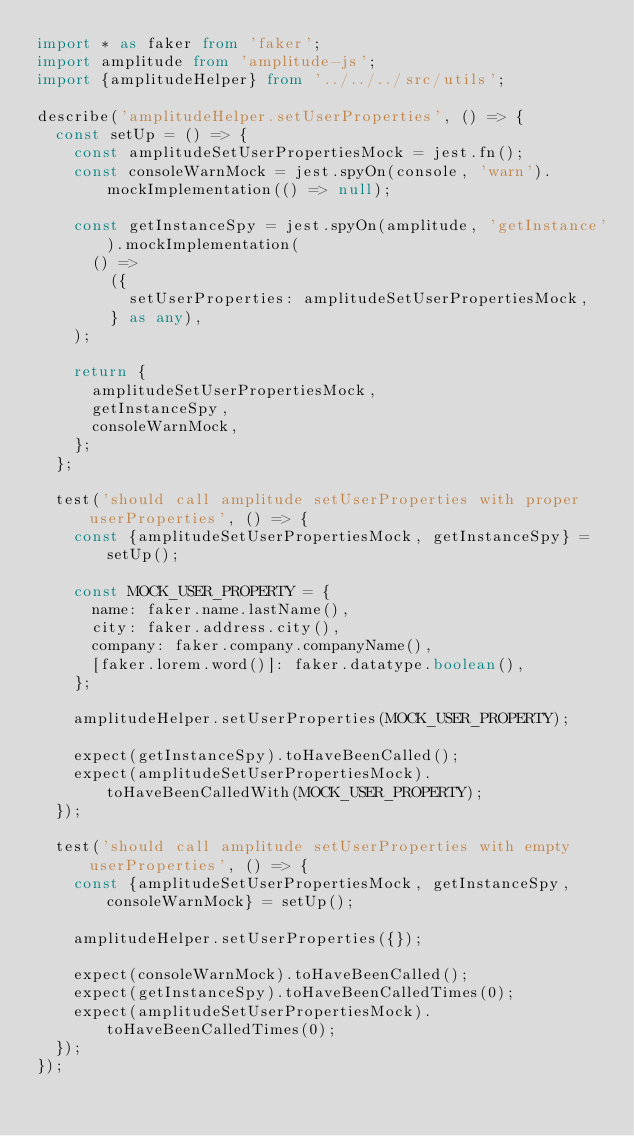<code> <loc_0><loc_0><loc_500><loc_500><_TypeScript_>import * as faker from 'faker';
import amplitude from 'amplitude-js';
import {amplitudeHelper} from '../../../src/utils';

describe('amplitudeHelper.setUserProperties', () => {
  const setUp = () => {
    const amplitudeSetUserPropertiesMock = jest.fn();
    const consoleWarnMock = jest.spyOn(console, 'warn').mockImplementation(() => null);

    const getInstanceSpy = jest.spyOn(amplitude, 'getInstance').mockImplementation(
      () =>
        ({
          setUserProperties: amplitudeSetUserPropertiesMock,
        } as any),
    );

    return {
      amplitudeSetUserPropertiesMock,
      getInstanceSpy,
      consoleWarnMock,
    };
  };

  test('should call amplitude setUserProperties with proper userProperties', () => {
    const {amplitudeSetUserPropertiesMock, getInstanceSpy} = setUp();

    const MOCK_USER_PROPERTY = {
      name: faker.name.lastName(),
      city: faker.address.city(),
      company: faker.company.companyName(),
      [faker.lorem.word()]: faker.datatype.boolean(),
    };

    amplitudeHelper.setUserProperties(MOCK_USER_PROPERTY);

    expect(getInstanceSpy).toHaveBeenCalled();
    expect(amplitudeSetUserPropertiesMock).toHaveBeenCalledWith(MOCK_USER_PROPERTY);
  });

  test('should call amplitude setUserProperties with empty userProperties', () => {
    const {amplitudeSetUserPropertiesMock, getInstanceSpy, consoleWarnMock} = setUp();

    amplitudeHelper.setUserProperties({});

    expect(consoleWarnMock).toHaveBeenCalled();
    expect(getInstanceSpy).toHaveBeenCalledTimes(0);
    expect(amplitudeSetUserPropertiesMock).toHaveBeenCalledTimes(0);
  });
});
</code> 